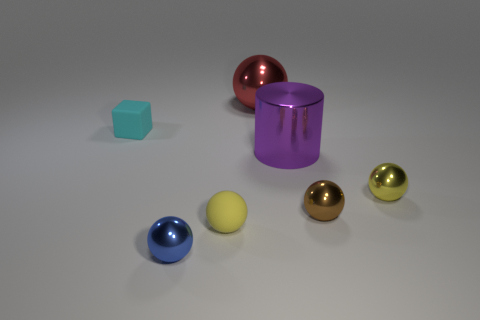Subtract all blue spheres. How many spheres are left? 4 Subtract all brown spheres. How many spheres are left? 4 Subtract all cyan spheres. Subtract all brown blocks. How many spheres are left? 5 Add 2 brown objects. How many objects exist? 9 Subtract all blocks. How many objects are left? 6 Subtract all tiny brown shiny balls. Subtract all large purple objects. How many objects are left? 5 Add 6 small matte cubes. How many small matte cubes are left? 7 Add 7 cylinders. How many cylinders exist? 8 Subtract 1 blue spheres. How many objects are left? 6 